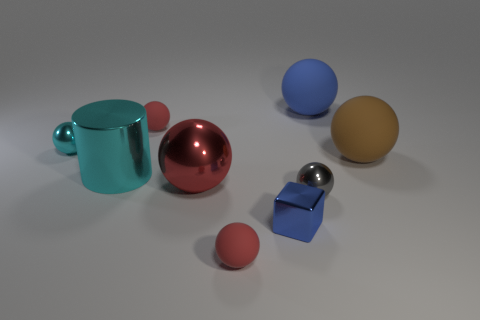There is a gray thing that is the same shape as the big brown thing; what size is it?
Make the answer very short. Small. What is the shape of the tiny thing that is in front of the brown sphere and on the left side of the tiny blue object?
Offer a terse response. Sphere. Does the blue ball have the same size as the cyan metallic thing that is behind the large cyan thing?
Your answer should be very brief. No. There is another big matte object that is the same shape as the brown object; what is its color?
Your response must be concise. Blue. Is the size of the red matte ball behind the big brown rubber object the same as the matte object in front of the big brown matte ball?
Your answer should be very brief. Yes. Do the tiny blue shiny object and the gray thing have the same shape?
Offer a very short reply. No. How many things are metallic objects that are on the left side of the big red sphere or brown rubber things?
Ensure brevity in your answer.  3. Are there any large purple matte things of the same shape as the small cyan thing?
Your response must be concise. No. Are there the same number of large blue matte spheres to the left of the large blue object and large red things?
Your response must be concise. No. How many red spheres have the same size as the brown rubber thing?
Your answer should be compact. 1. 